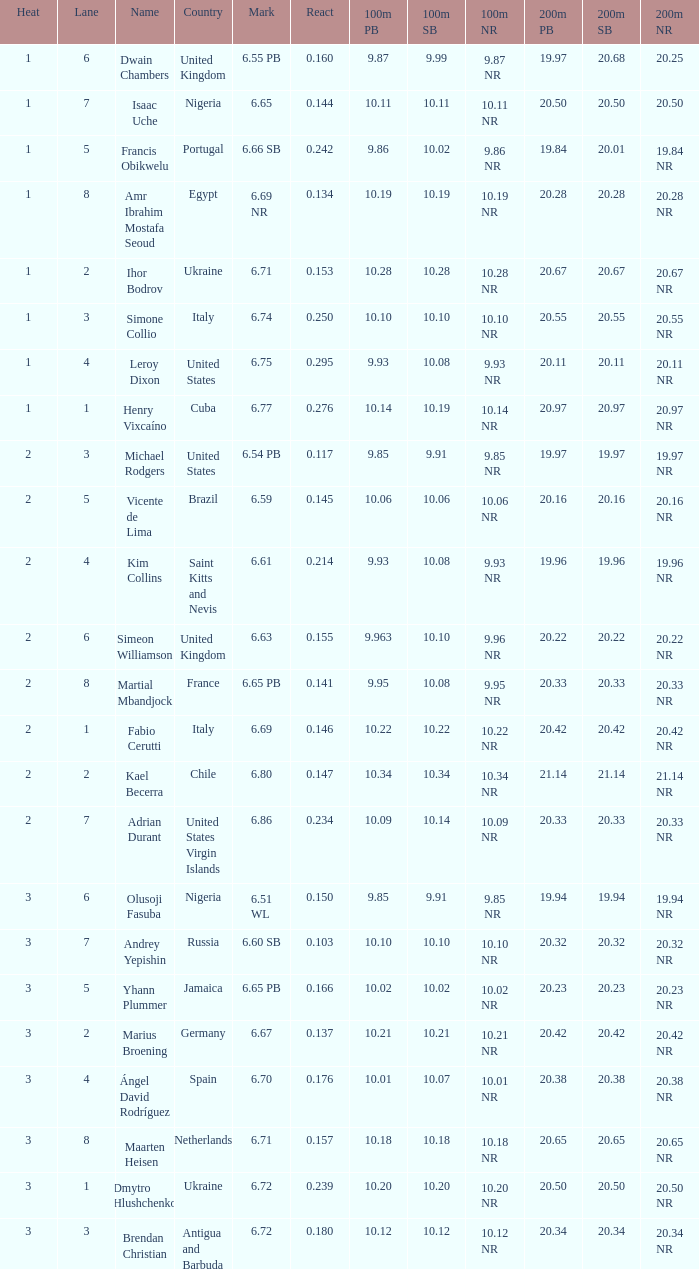What is Country, when Lane is 5, and when React is greater than 0.166? Portugal. 